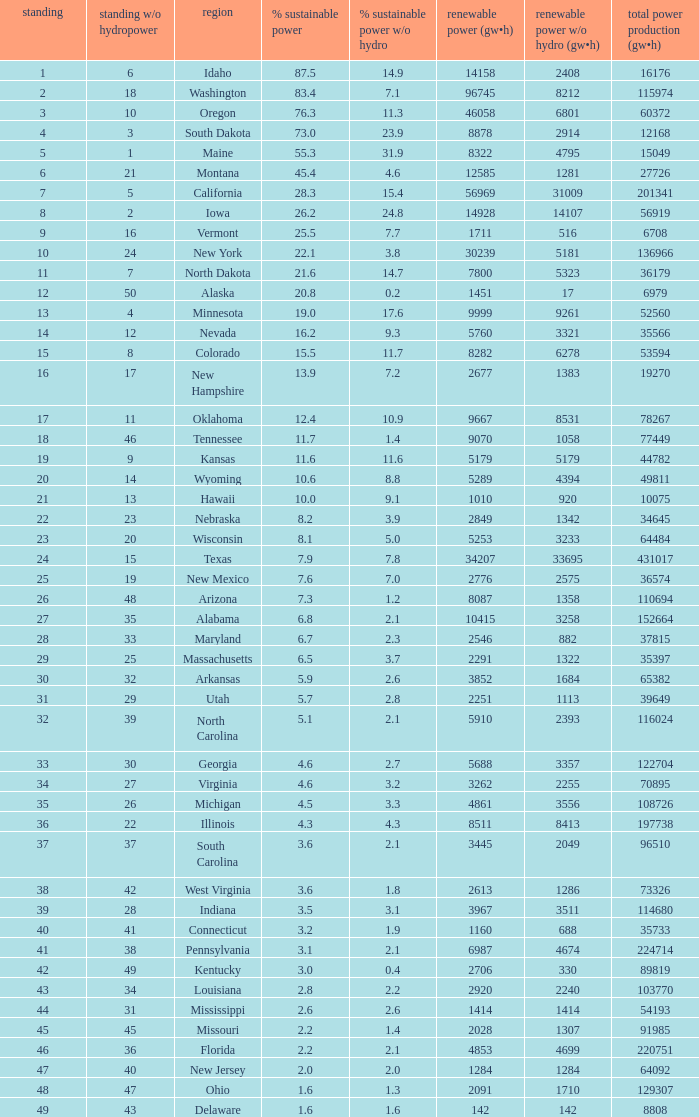What is the maximum renewable energy (gw×h) for the state of Delaware? 142.0. 